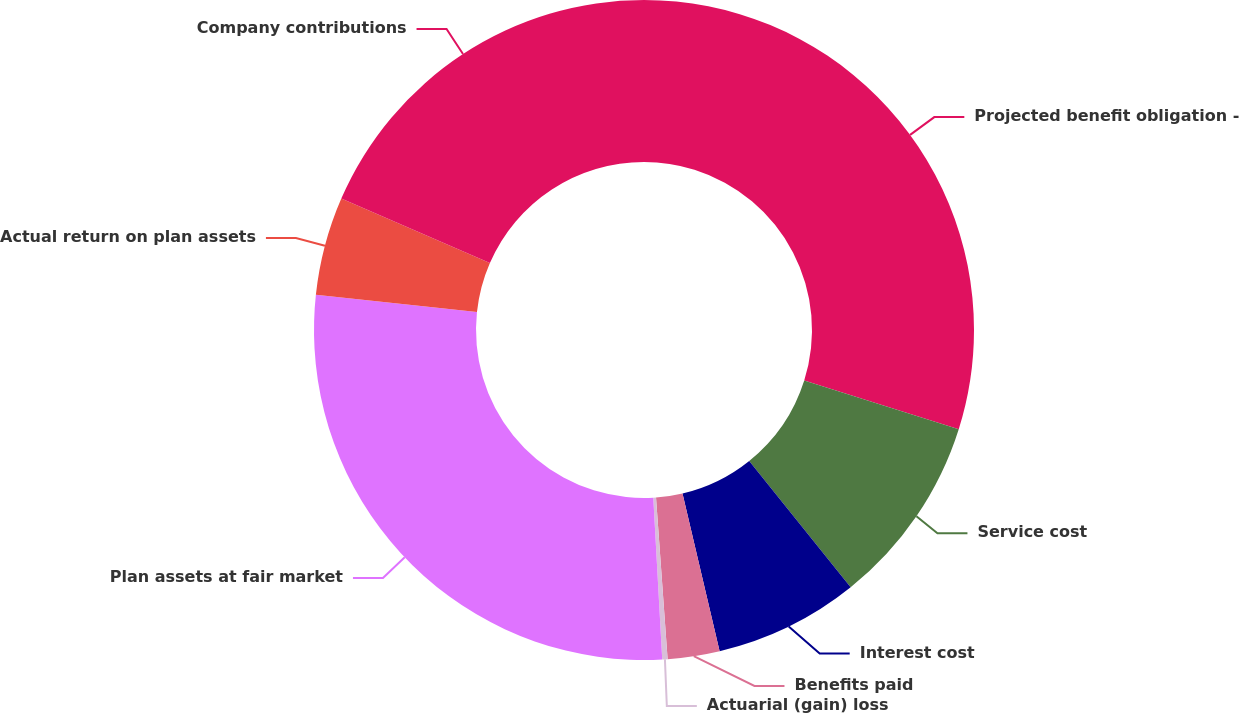<chart> <loc_0><loc_0><loc_500><loc_500><pie_chart><fcel>Projected benefit obligation -<fcel>Service cost<fcel>Interest cost<fcel>Benefits paid<fcel>Actuarial (gain) loss<fcel>Plan assets at fair market<fcel>Actual return on plan assets<fcel>Company contributions<nl><fcel>29.86%<fcel>9.37%<fcel>7.09%<fcel>2.54%<fcel>0.26%<fcel>27.58%<fcel>4.82%<fcel>18.48%<nl></chart> 